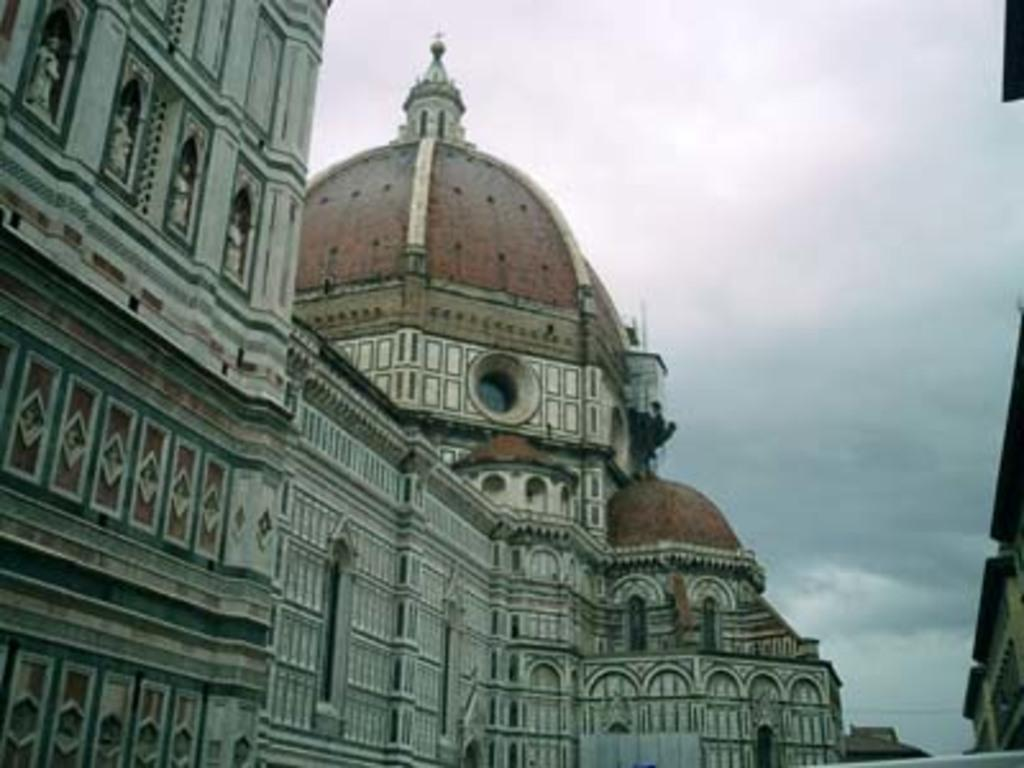What structures can be seen in the image? There are buildings in the image. What else is visible in the image besides the buildings? There is a cable visible in the image. How would you describe the sky in the image? The sky in the image appears cloudy. Can you see any cobwebs hanging from the buildings in the image? There is no mention of cobwebs in the image, so we cannot determine if any are present. What type of trouble might the cable be causing in the image? The image does not provide any information about the cable causing trouble, so we cannot determine if it is or not. 